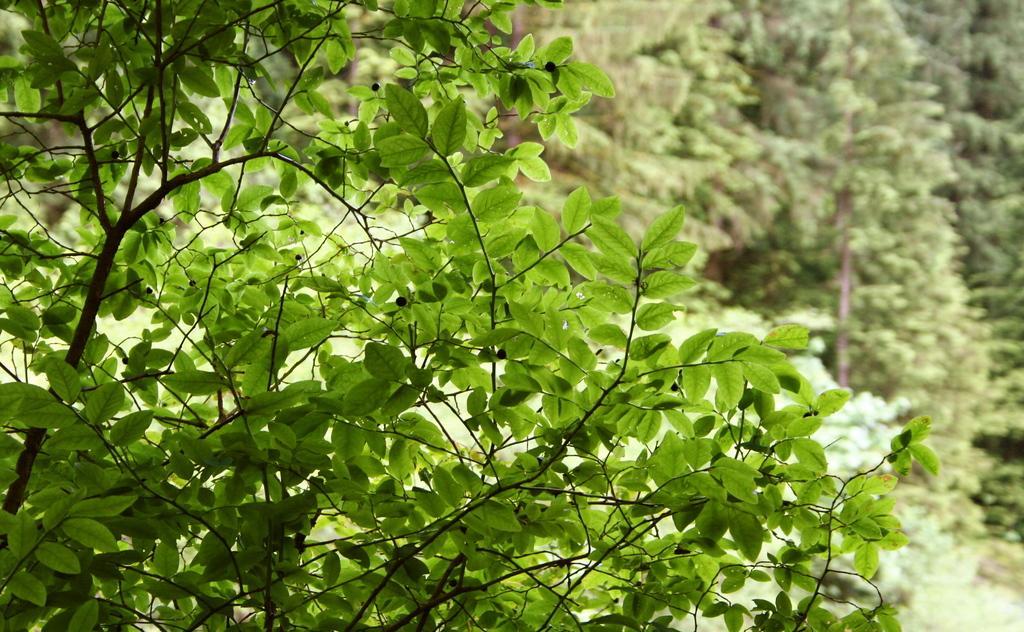How would you summarize this image in a sentence or two? On the left side of this image I can see the green color leaves of a plant. In the background there are many trees. 